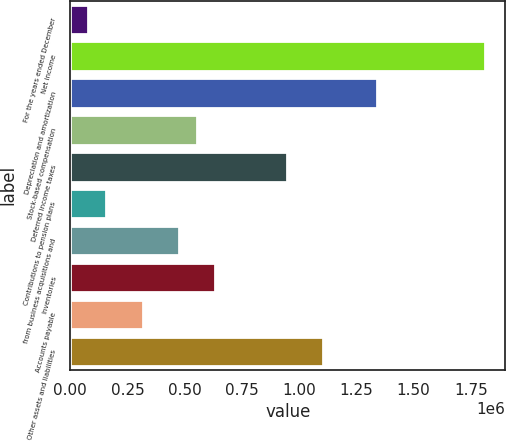<chart> <loc_0><loc_0><loc_500><loc_500><bar_chart><fcel>For the years ended December<fcel>Net income<fcel>Depreciation and amortization<fcel>Stock-based compensation<fcel>Deferred income taxes<fcel>Contributions to pension plans<fcel>from business acquisitions and<fcel>Inventories<fcel>Accounts payable<fcel>Other assets and liabilities<nl><fcel>79570.1<fcel>1.81069e+06<fcel>1.33856e+06<fcel>551693<fcel>945128<fcel>158257<fcel>473006<fcel>630380<fcel>315631<fcel>1.1025e+06<nl></chart> 